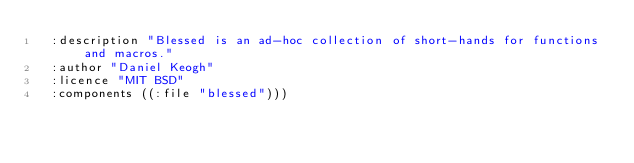Convert code to text. <code><loc_0><loc_0><loc_500><loc_500><_Lisp_>  :description "Blessed is an ad-hoc collection of short-hands for functions and macros."
  :author "Daniel Keogh"
  :licence "MIT BSD"
  :components ((:file "blessed")))
</code> 